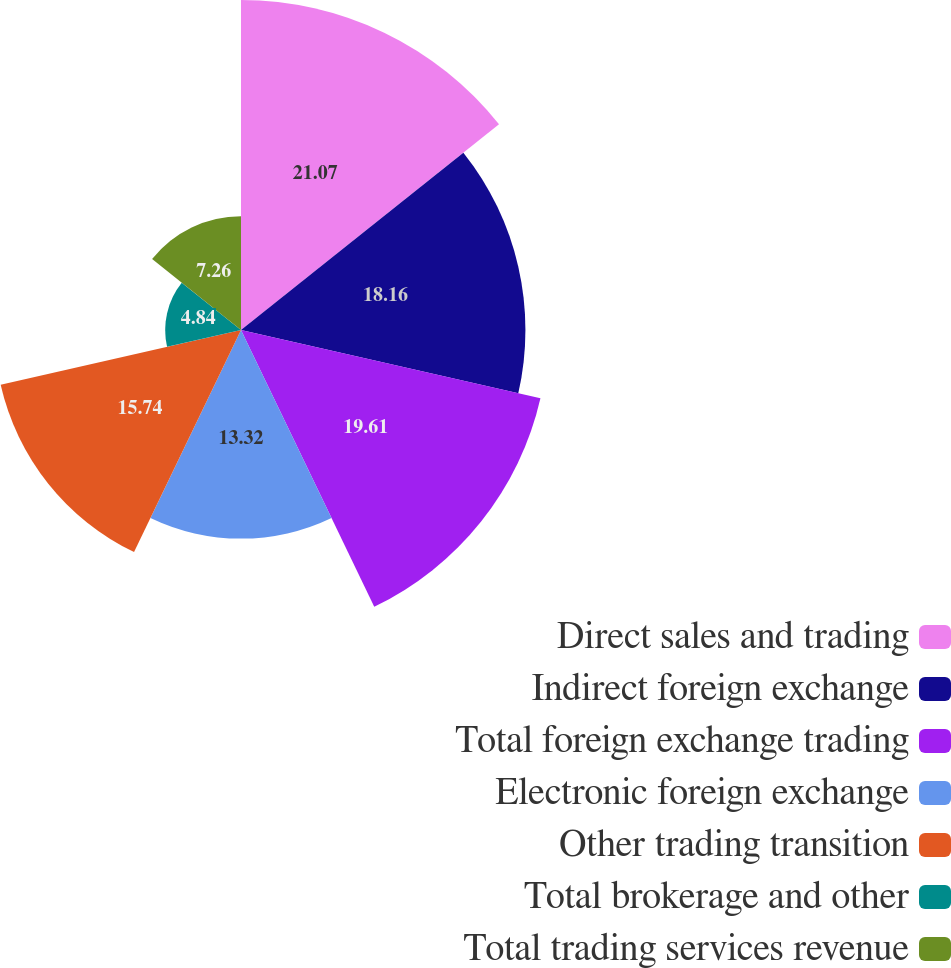Convert chart. <chart><loc_0><loc_0><loc_500><loc_500><pie_chart><fcel>Direct sales and trading<fcel>Indirect foreign exchange<fcel>Total foreign exchange trading<fcel>Electronic foreign exchange<fcel>Other trading transition<fcel>Total brokerage and other<fcel>Total trading services revenue<nl><fcel>21.07%<fcel>18.16%<fcel>19.61%<fcel>13.32%<fcel>15.74%<fcel>4.84%<fcel>7.26%<nl></chart> 